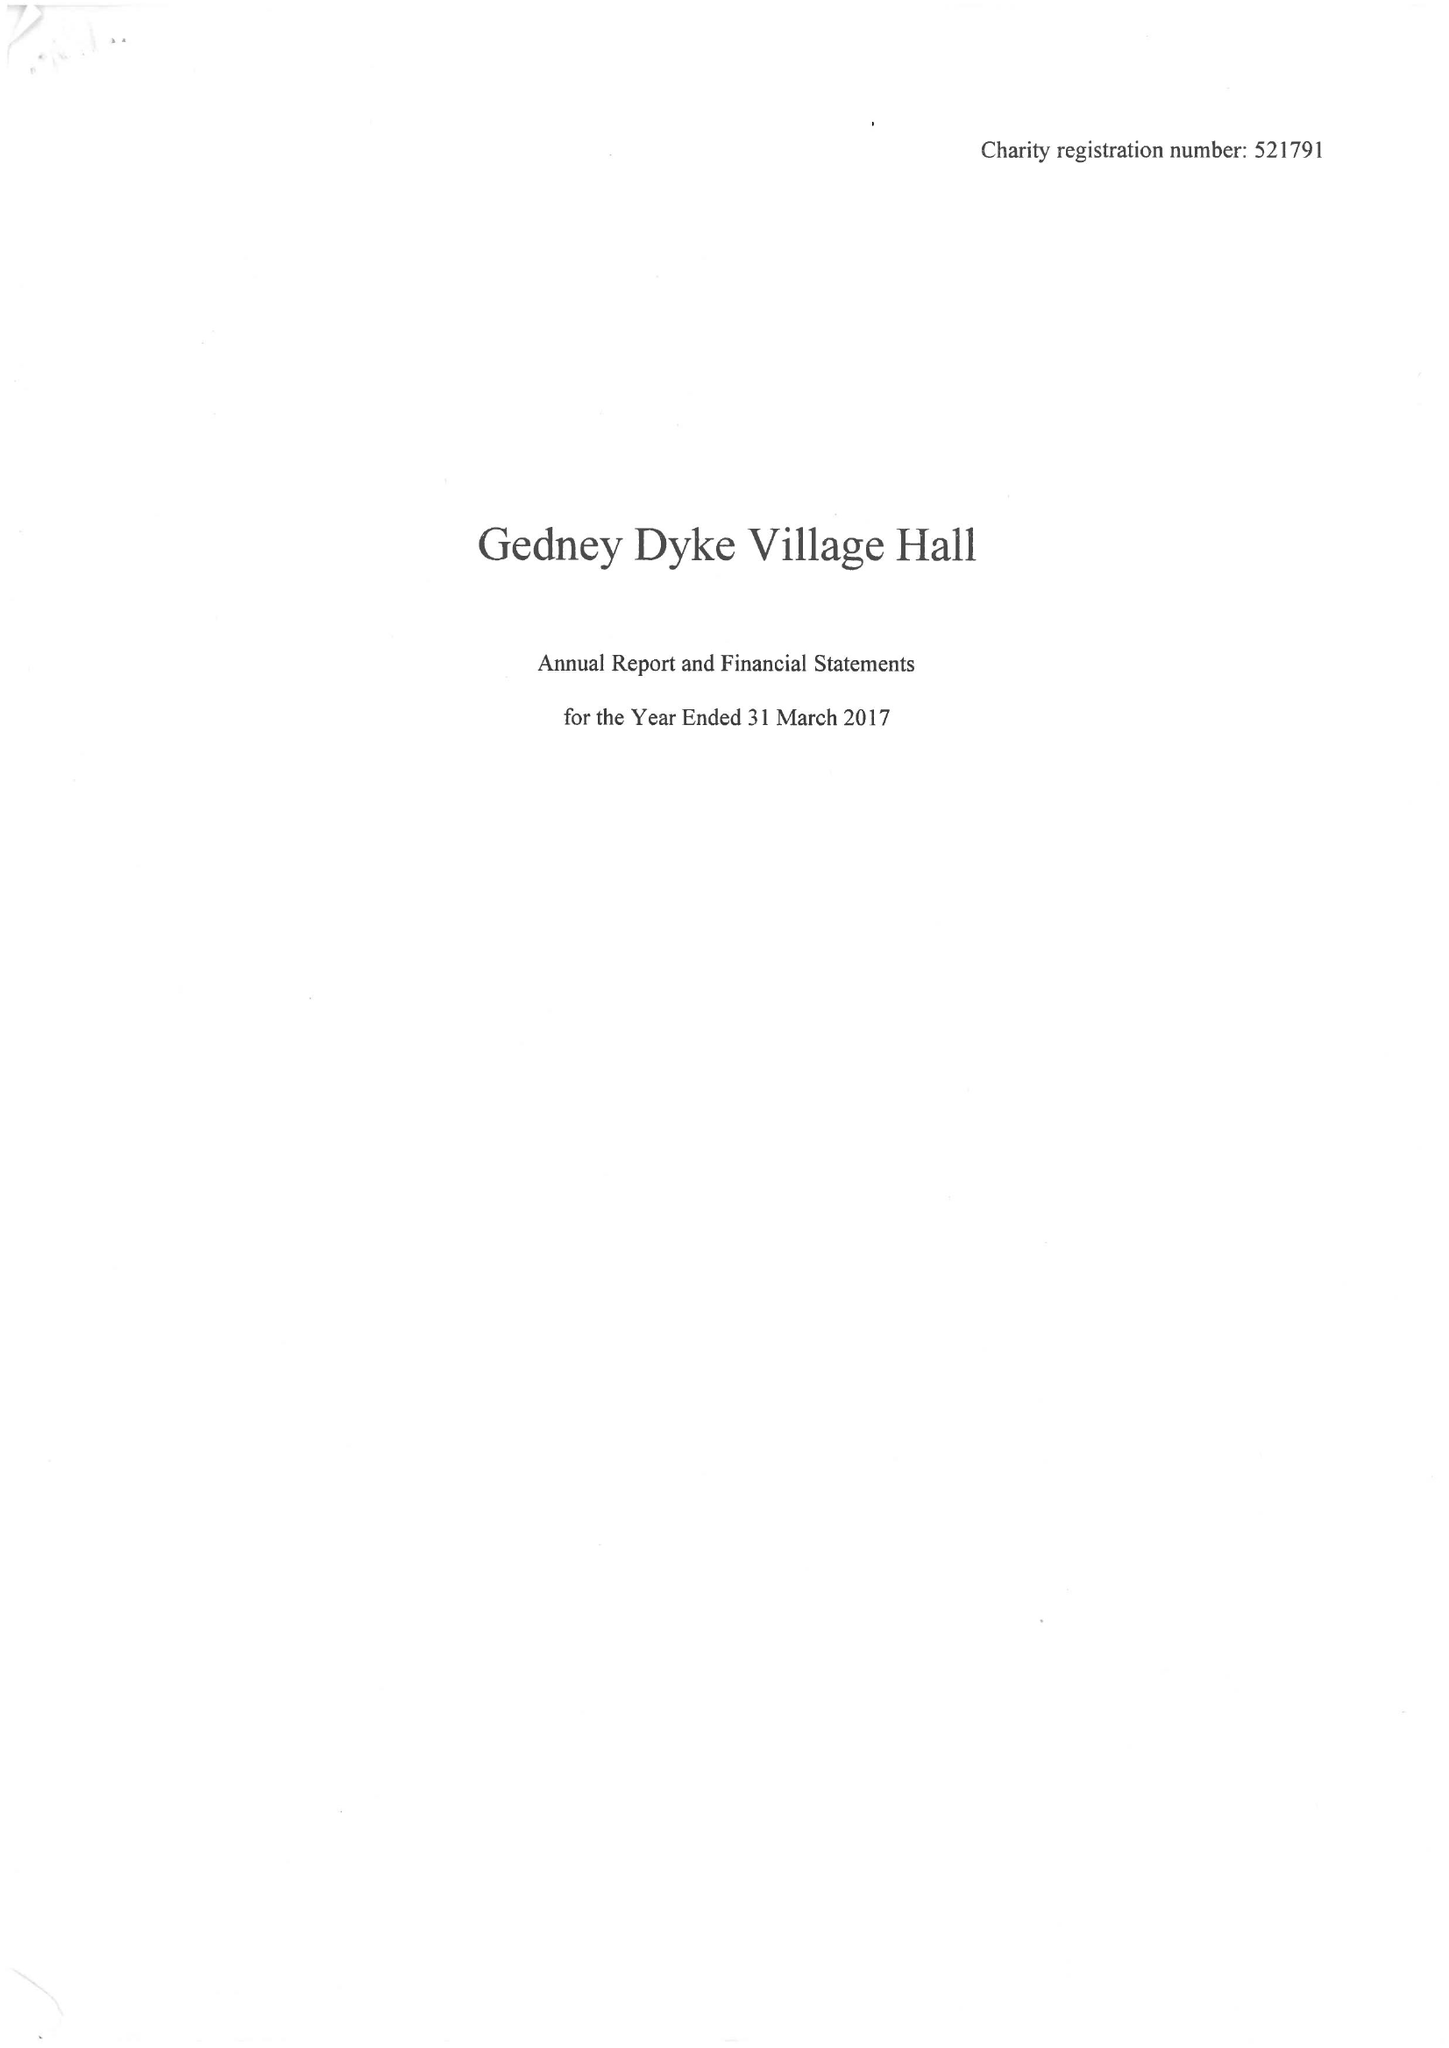What is the value for the address__postcode?
Answer the question using a single word or phrase. PE12 0AJ 